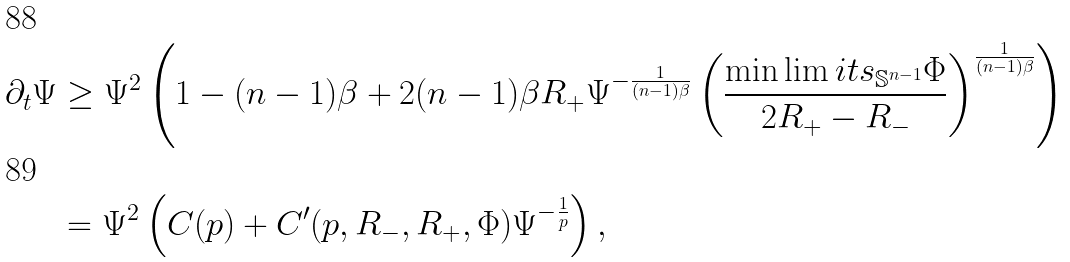Convert formula to latex. <formula><loc_0><loc_0><loc_500><loc_500>\partial _ { t } \Psi & \geq \Psi ^ { 2 } \left ( 1 - ( n - 1 ) \beta + 2 ( n - 1 ) \beta R _ { + } \Psi ^ { - \frac { 1 } { ( n - 1 ) \beta } } \left ( \frac { \min \lim i t s _ { \mathbb { S } ^ { n - 1 } } \Phi } { 2 R _ { + } - R _ { - } } \right ) ^ { \frac { 1 } { ( n - 1 ) \beta } } \right ) \\ & = \Psi ^ { 2 } \left ( C ( p ) + C ^ { \prime } ( p , R _ { - } , R _ { + } , \Phi ) \Psi ^ { - \frac { 1 } { p } } \right ) ,</formula> 